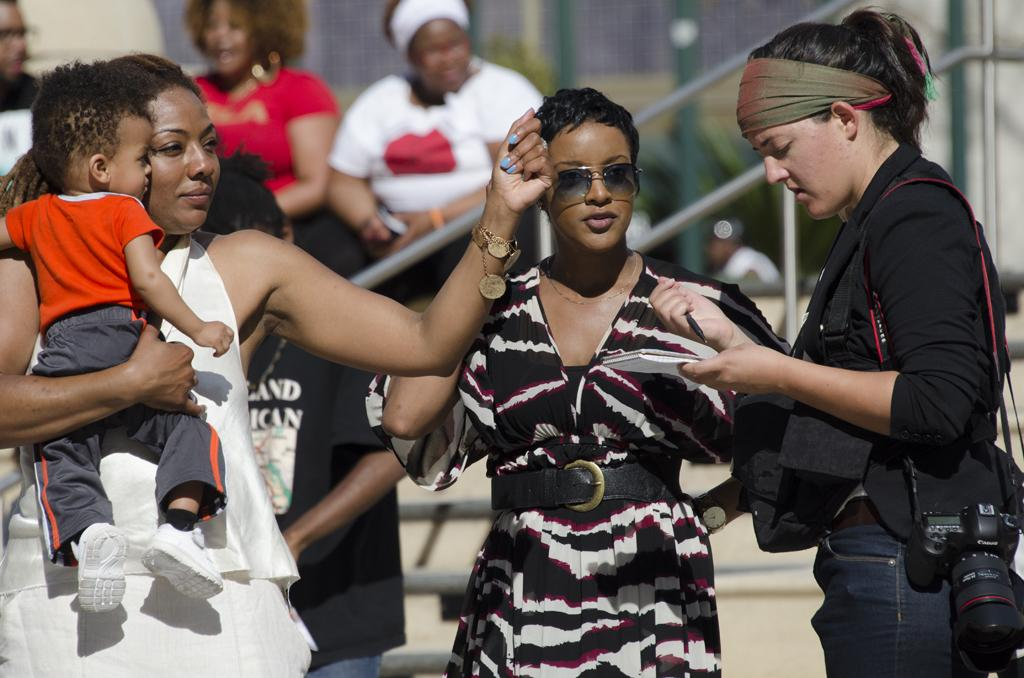What can be seen in the image involving multiple individuals? There is a group of people in the image. What object is present that is commonly used for capturing images? There is a camera in the image. What type of long, thin objects are visible in the image? There are rods in the image. How would you describe the background of the image? The background of the image is blurry. What type of voice can be heard in the image? There is no voice present in the image, as it is a still image and not a video or audio recording. What event is taking place in the image? The image does not depict a specific event; it simply shows a group of people, a camera, and rods with a blurry background. 